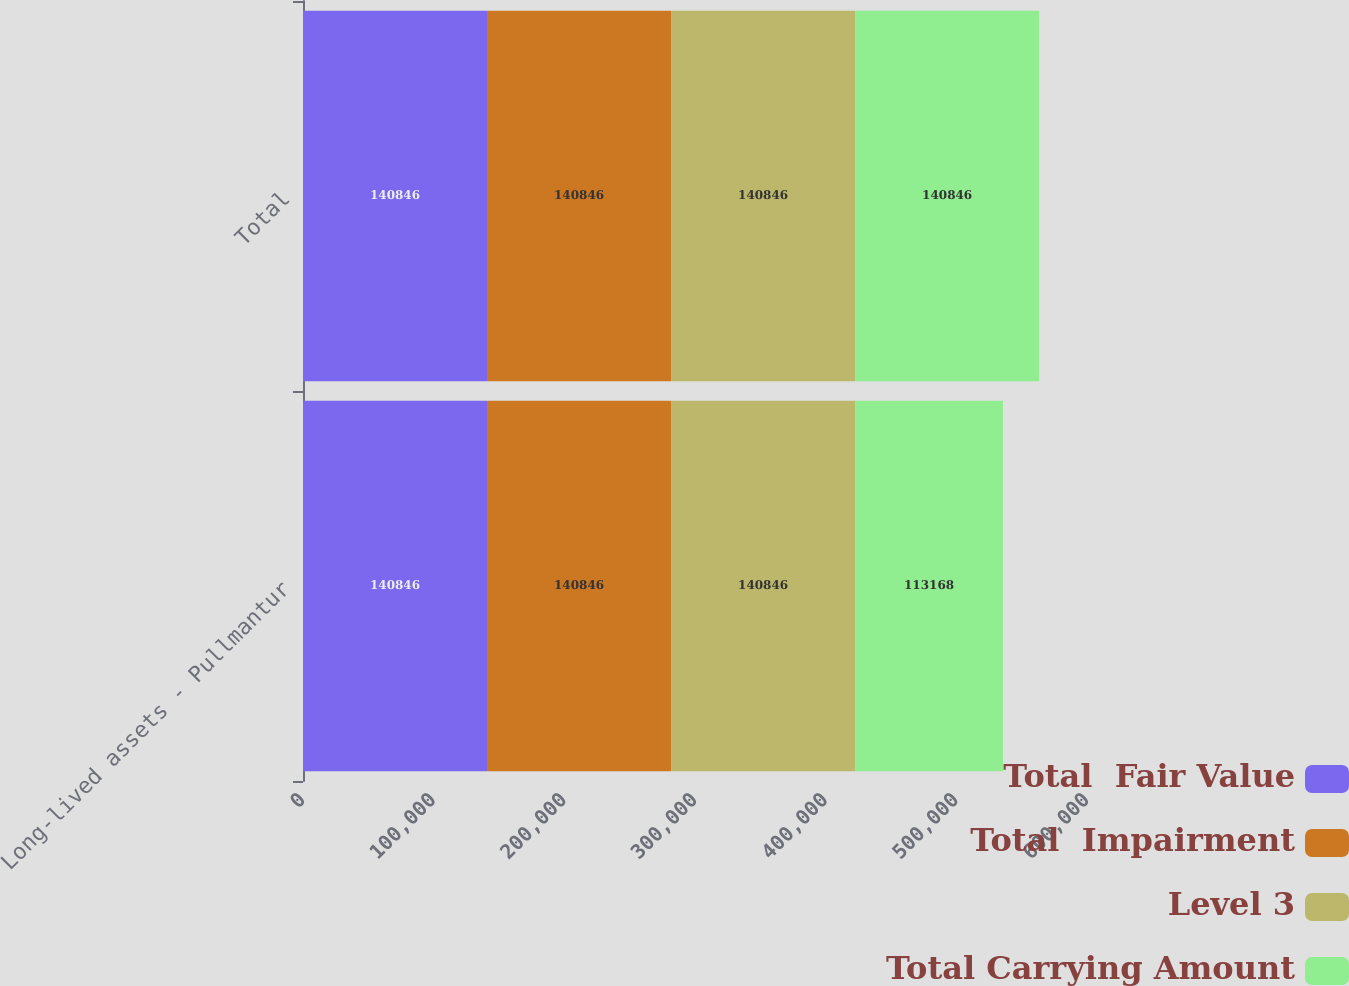<chart> <loc_0><loc_0><loc_500><loc_500><stacked_bar_chart><ecel><fcel>Long-lived assets - Pullmantur<fcel>Total<nl><fcel>Total  Fair Value<fcel>140846<fcel>140846<nl><fcel>Total  Impairment<fcel>140846<fcel>140846<nl><fcel>Level 3<fcel>140846<fcel>140846<nl><fcel>Total Carrying Amount<fcel>113168<fcel>140846<nl></chart> 